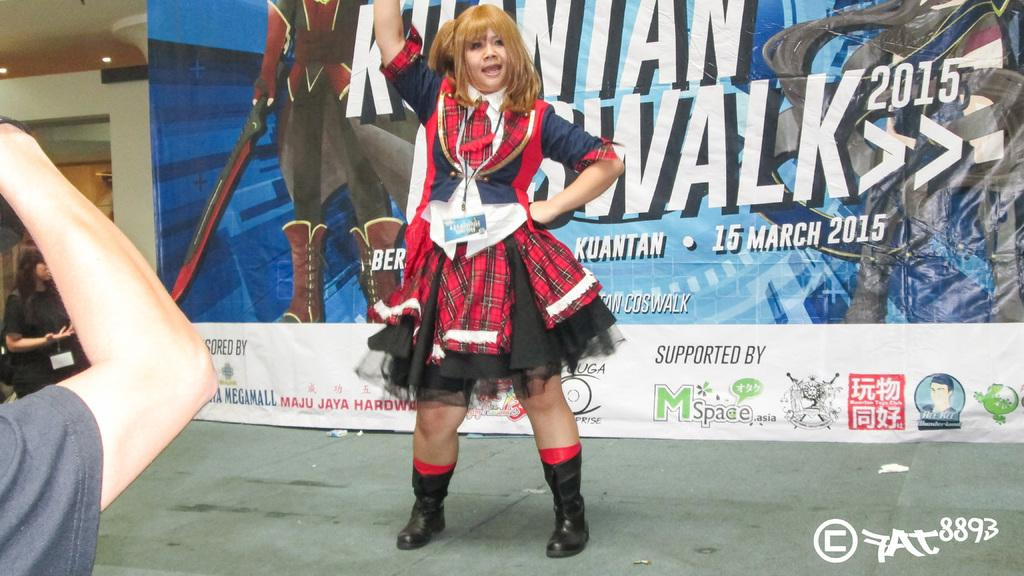Provide a one-sentence caption for the provided image. A woman poses for photos in front of a sign that indicates this event was happening in 2015. 